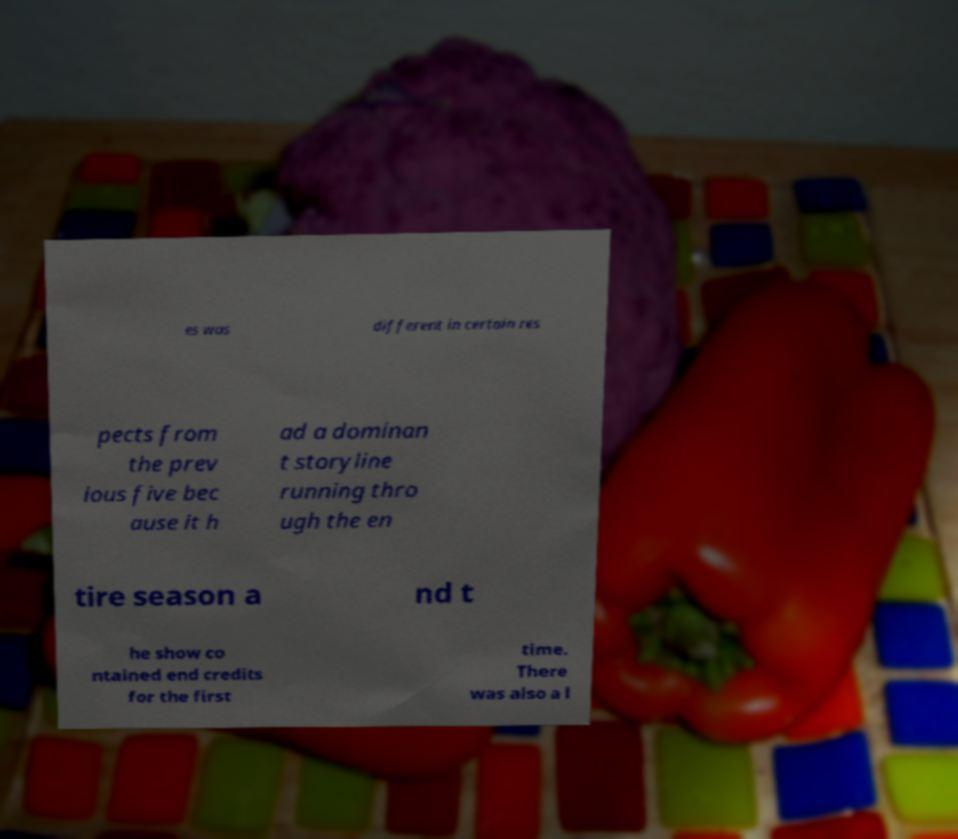What messages or text are displayed in this image? I need them in a readable, typed format. es was different in certain res pects from the prev ious five bec ause it h ad a dominan t storyline running thro ugh the en tire season a nd t he show co ntained end credits for the first time. There was also a l 